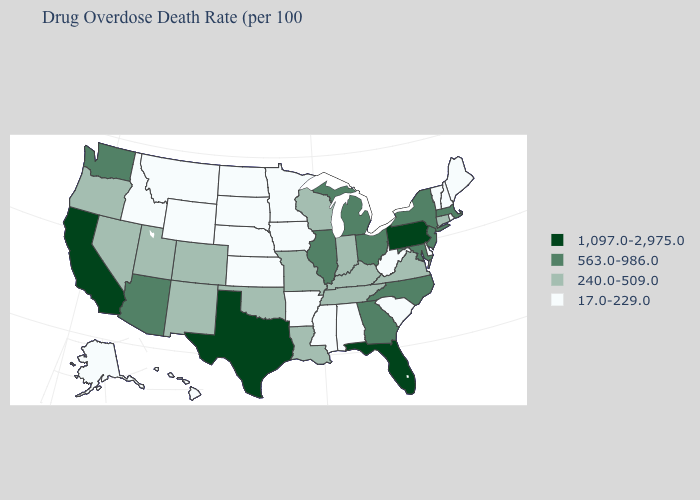Does the map have missing data?
Write a very short answer. No. Among the states that border New Hampshire , does Massachusetts have the lowest value?
Write a very short answer. No. What is the value of New Mexico?
Answer briefly. 240.0-509.0. Does Maine have the lowest value in the Northeast?
Be succinct. Yes. Does the first symbol in the legend represent the smallest category?
Be succinct. No. Name the states that have a value in the range 563.0-986.0?
Short answer required. Arizona, Georgia, Illinois, Maryland, Massachusetts, Michigan, New Jersey, New York, North Carolina, Ohio, Washington. What is the lowest value in states that border New York?
Short answer required. 17.0-229.0. What is the highest value in the USA?
Be succinct. 1,097.0-2,975.0. What is the value of West Virginia?
Answer briefly. 17.0-229.0. What is the value of Colorado?
Concise answer only. 240.0-509.0. What is the value of Oklahoma?
Concise answer only. 240.0-509.0. Which states have the lowest value in the Northeast?
Write a very short answer. Maine, New Hampshire, Rhode Island, Vermont. Does Rhode Island have the lowest value in the USA?
Short answer required. Yes. Name the states that have a value in the range 563.0-986.0?
Be succinct. Arizona, Georgia, Illinois, Maryland, Massachusetts, Michigan, New Jersey, New York, North Carolina, Ohio, Washington. 